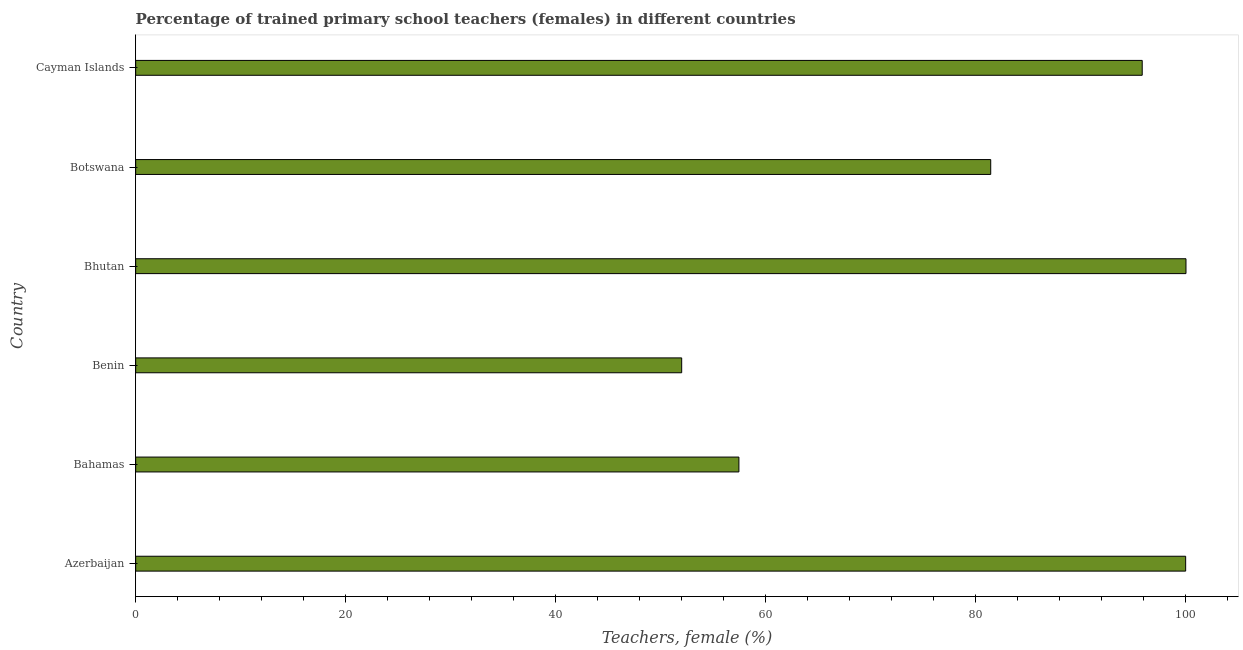What is the title of the graph?
Make the answer very short. Percentage of trained primary school teachers (females) in different countries. What is the label or title of the X-axis?
Your answer should be very brief. Teachers, female (%). What is the label or title of the Y-axis?
Offer a terse response. Country. What is the percentage of trained female teachers in Bhutan?
Offer a terse response. 100. Across all countries, what is the maximum percentage of trained female teachers?
Your answer should be compact. 100. Across all countries, what is the minimum percentage of trained female teachers?
Give a very brief answer. 51.99. In which country was the percentage of trained female teachers maximum?
Ensure brevity in your answer.  Bhutan. In which country was the percentage of trained female teachers minimum?
Provide a short and direct response. Benin. What is the sum of the percentage of trained female teachers?
Provide a short and direct response. 486.63. What is the difference between the percentage of trained female teachers in Benin and Cayman Islands?
Offer a terse response. -43.85. What is the average percentage of trained female teachers per country?
Your answer should be compact. 81.11. What is the median percentage of trained female teachers?
Keep it short and to the point. 88.62. In how many countries, is the percentage of trained female teachers greater than 52 %?
Your response must be concise. 5. What is the ratio of the percentage of trained female teachers in Azerbaijan to that in Cayman Islands?
Offer a terse response. 1.04. Is the percentage of trained female teachers in Bhutan less than that in Cayman Islands?
Your response must be concise. No. Is the difference between the percentage of trained female teachers in Bahamas and Benin greater than the difference between any two countries?
Keep it short and to the point. No. What is the difference between the highest and the second highest percentage of trained female teachers?
Your response must be concise. 0.03. What is the difference between the highest and the lowest percentage of trained female teachers?
Give a very brief answer. 48.01. In how many countries, is the percentage of trained female teachers greater than the average percentage of trained female teachers taken over all countries?
Your response must be concise. 4. How many bars are there?
Your answer should be compact. 6. Are the values on the major ticks of X-axis written in scientific E-notation?
Make the answer very short. No. What is the Teachers, female (%) of Azerbaijan?
Keep it short and to the point. 99.97. What is the Teachers, female (%) of Bahamas?
Keep it short and to the point. 57.43. What is the Teachers, female (%) in Benin?
Your answer should be compact. 51.99. What is the Teachers, female (%) of Bhutan?
Keep it short and to the point. 100. What is the Teachers, female (%) of Botswana?
Your answer should be very brief. 81.41. What is the Teachers, female (%) of Cayman Islands?
Offer a terse response. 95.83. What is the difference between the Teachers, female (%) in Azerbaijan and Bahamas?
Your answer should be very brief. 42.53. What is the difference between the Teachers, female (%) in Azerbaijan and Benin?
Ensure brevity in your answer.  47.98. What is the difference between the Teachers, female (%) in Azerbaijan and Bhutan?
Offer a very short reply. -0.03. What is the difference between the Teachers, female (%) in Azerbaijan and Botswana?
Give a very brief answer. 18.56. What is the difference between the Teachers, female (%) in Azerbaijan and Cayman Islands?
Keep it short and to the point. 4.14. What is the difference between the Teachers, female (%) in Bahamas and Benin?
Give a very brief answer. 5.45. What is the difference between the Teachers, female (%) in Bahamas and Bhutan?
Offer a terse response. -42.57. What is the difference between the Teachers, female (%) in Bahamas and Botswana?
Give a very brief answer. -23.97. What is the difference between the Teachers, female (%) in Bahamas and Cayman Islands?
Provide a short and direct response. -38.4. What is the difference between the Teachers, female (%) in Benin and Bhutan?
Your response must be concise. -48.01. What is the difference between the Teachers, female (%) in Benin and Botswana?
Keep it short and to the point. -29.42. What is the difference between the Teachers, female (%) in Benin and Cayman Islands?
Give a very brief answer. -43.85. What is the difference between the Teachers, female (%) in Bhutan and Botswana?
Your answer should be compact. 18.59. What is the difference between the Teachers, female (%) in Bhutan and Cayman Islands?
Make the answer very short. 4.17. What is the difference between the Teachers, female (%) in Botswana and Cayman Islands?
Offer a terse response. -14.42. What is the ratio of the Teachers, female (%) in Azerbaijan to that in Bahamas?
Your answer should be very brief. 1.74. What is the ratio of the Teachers, female (%) in Azerbaijan to that in Benin?
Offer a terse response. 1.92. What is the ratio of the Teachers, female (%) in Azerbaijan to that in Bhutan?
Keep it short and to the point. 1. What is the ratio of the Teachers, female (%) in Azerbaijan to that in Botswana?
Provide a short and direct response. 1.23. What is the ratio of the Teachers, female (%) in Azerbaijan to that in Cayman Islands?
Your answer should be compact. 1.04. What is the ratio of the Teachers, female (%) in Bahamas to that in Benin?
Ensure brevity in your answer.  1.1. What is the ratio of the Teachers, female (%) in Bahamas to that in Bhutan?
Ensure brevity in your answer.  0.57. What is the ratio of the Teachers, female (%) in Bahamas to that in Botswana?
Your answer should be very brief. 0.71. What is the ratio of the Teachers, female (%) in Bahamas to that in Cayman Islands?
Make the answer very short. 0.6. What is the ratio of the Teachers, female (%) in Benin to that in Bhutan?
Your answer should be compact. 0.52. What is the ratio of the Teachers, female (%) in Benin to that in Botswana?
Ensure brevity in your answer.  0.64. What is the ratio of the Teachers, female (%) in Benin to that in Cayman Islands?
Provide a short and direct response. 0.54. What is the ratio of the Teachers, female (%) in Bhutan to that in Botswana?
Offer a terse response. 1.23. What is the ratio of the Teachers, female (%) in Bhutan to that in Cayman Islands?
Provide a short and direct response. 1.04. What is the ratio of the Teachers, female (%) in Botswana to that in Cayman Islands?
Provide a succinct answer. 0.85. 